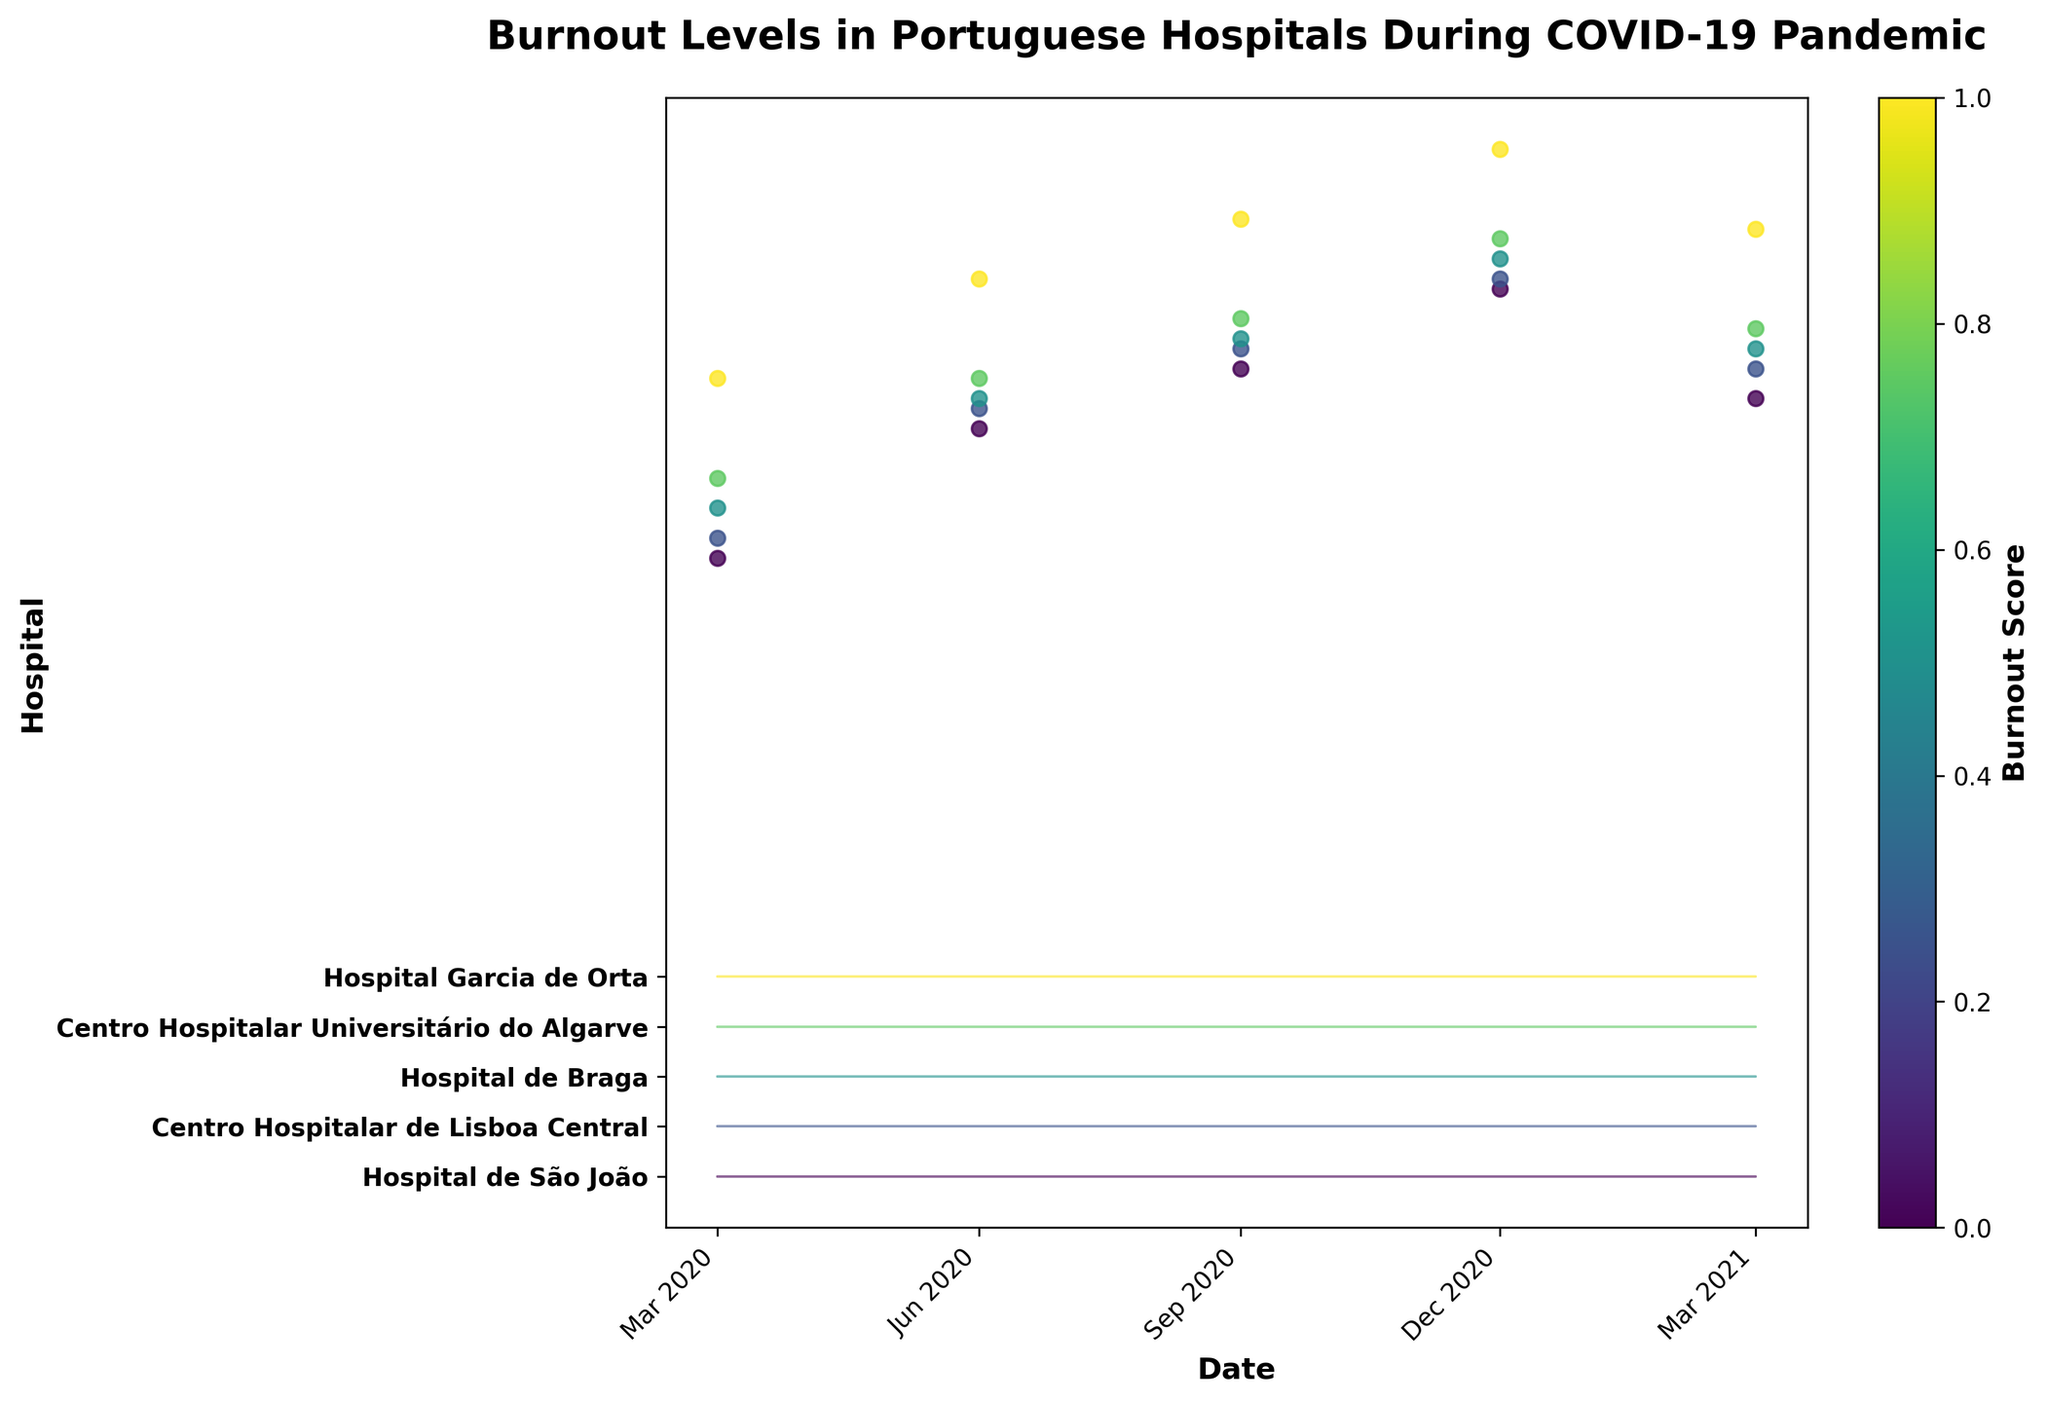Which hospital shows the highest burnout score at any given time? Look at the peaks of each hospital's burnout score line. Hospital de São João shows the highest peak burnout score of 8.9 around December 2020.
Answer: Hospital de São João How many hospitals are represented in the figure? Identify the number of distinct y-tick labels that correspond to different hospitals in the figure. There are five different hospitals listed on the y-axis.
Answer: 5 Which hospital's burnout levels peaked earliest in the pandemic? Determine which hospital first hits its peak burnout score by looking for the earliest high point in each hospital's line. Hospital de São João had the earliest peak around June 2020.
Answer: Hospital de São João During which time period did the most rapid increase in burnout levels occur across hospitals? Compare the slopes of burnout score increases for each time period across all hospitals. The most rapid increases are seen between March 2020 and June 2020.
Answer: March to June 2020 What is the trend of burnout levels at the Centro Hospitalar Universitário do Algarve from March 2020 to March 2021? Observe the changes in burnout scores at each time point for that hospital. Burnout levels at Centro Hospitalar Universitário do Algarve increased from 5.5 in March 2020 to a peak of 7.9 in December 2020 and then decreased slightly to 7.0 by March 2021.
Answer: Increasing, peaking in December 2020, then slight decrease Which hospital had the smallest increase in burnout levels from March 2020 to March 2021? Calculate the difference between the burnout scores in March 2021 and March 2020 for all hospitals and find the smallest value. Hospital Garcia de Orta had an increase from 6.0 to 7.5 (1.5), which is the smallest increase.
Answer: Hospital Garcia de Orta What’s the difference in burnout scores between the highest and lowest scoring hospitals in December 2020? Identify the highest and lowest burnout scores for December 2020 and find the difference. Hospital de São João had the highest score (8.9) and Centro Hospitalar Universitário do Algarve had the lowest (7.9). The difference is 1.0.
Answer: 1.0 Which hospital experienced the most consistent level of burnout (least fluctuation) throughout the pandemic? Compare the range (max-min) of burnout scores for each hospital. Hospital Garcia de Orta fluctuated between 6.0 and 8.3, which is the narrowest range compared to others.
Answer: Hospital Garcia de Orta 